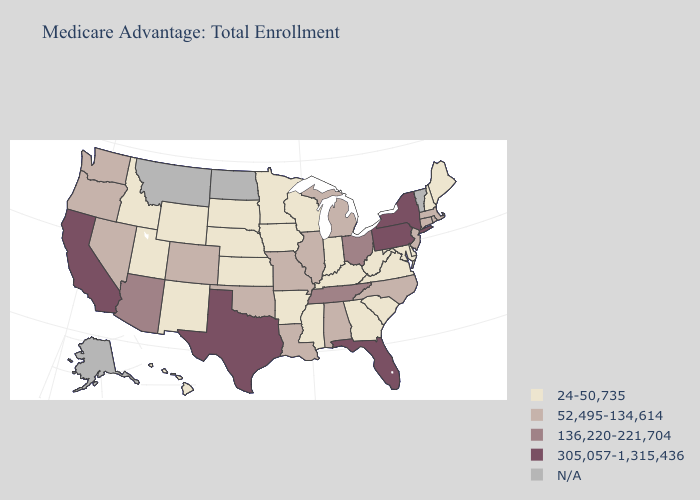Name the states that have a value in the range 52,495-134,614?
Answer briefly. Alabama, Colorado, Connecticut, Illinois, Louisiana, Massachusetts, Michigan, Missouri, North Carolina, New Jersey, Nevada, Oklahoma, Oregon, Rhode Island, Washington. What is the highest value in the USA?
Concise answer only. 305,057-1,315,436. Does Missouri have the highest value in the USA?
Answer briefly. No. Which states have the lowest value in the West?
Answer briefly. Hawaii, Idaho, New Mexico, Utah, Wyoming. Name the states that have a value in the range 52,495-134,614?
Give a very brief answer. Alabama, Colorado, Connecticut, Illinois, Louisiana, Massachusetts, Michigan, Missouri, North Carolina, New Jersey, Nevada, Oklahoma, Oregon, Rhode Island, Washington. Does Oregon have the lowest value in the USA?
Keep it brief. No. Name the states that have a value in the range 24-50,735?
Be succinct. Arkansas, Delaware, Georgia, Hawaii, Iowa, Idaho, Indiana, Kansas, Kentucky, Maryland, Maine, Minnesota, Mississippi, Nebraska, New Hampshire, New Mexico, South Carolina, South Dakota, Utah, Virginia, Wisconsin, West Virginia, Wyoming. Name the states that have a value in the range 136,220-221,704?
Be succinct. Arizona, Ohio, Tennessee. Name the states that have a value in the range 136,220-221,704?
Answer briefly. Arizona, Ohio, Tennessee. Does the first symbol in the legend represent the smallest category?
Quick response, please. Yes. Among the states that border Arizona , does California have the highest value?
Be succinct. Yes. Name the states that have a value in the range N/A?
Concise answer only. Alaska, Montana, North Dakota, Vermont. Name the states that have a value in the range 52,495-134,614?
Concise answer only. Alabama, Colorado, Connecticut, Illinois, Louisiana, Massachusetts, Michigan, Missouri, North Carolina, New Jersey, Nevada, Oklahoma, Oregon, Rhode Island, Washington. Name the states that have a value in the range 24-50,735?
Be succinct. Arkansas, Delaware, Georgia, Hawaii, Iowa, Idaho, Indiana, Kansas, Kentucky, Maryland, Maine, Minnesota, Mississippi, Nebraska, New Hampshire, New Mexico, South Carolina, South Dakota, Utah, Virginia, Wisconsin, West Virginia, Wyoming. 